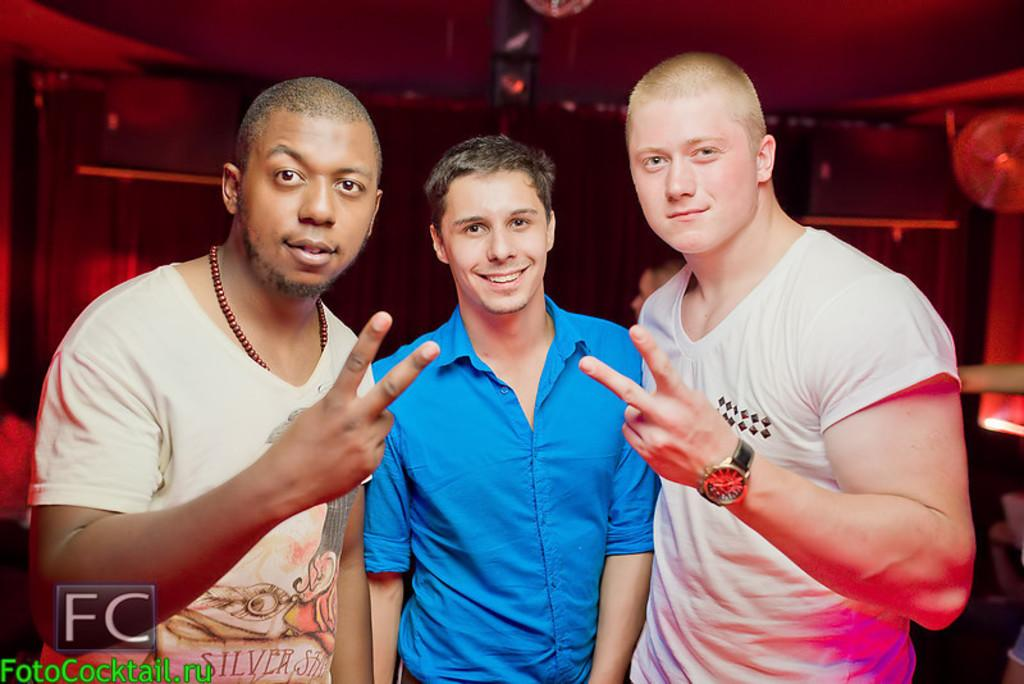How many people are in the image? There are three men standing in the image. What is the facial expression of the men in the image? The men are smiling. Can you describe the background of the image? There is an object visible in the background of the image. Is there any additional information about the image itself? Yes, there is a watermark on the image. Can you tell me how many steps the goose took in the image? There is no goose present in the image, so it is not possible to determine how many steps it took. What type of hospital is visible in the image? There is no hospital visible in the image. 